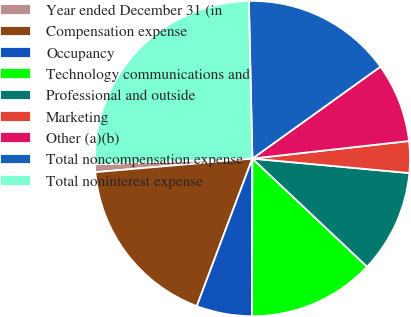<chart> <loc_0><loc_0><loc_500><loc_500><pie_chart><fcel>Year ended December 31 (in<fcel>Compensation expense<fcel>Occupancy<fcel>Technology communications and<fcel>Professional and outside<fcel>Marketing<fcel>Other (a)(b)<fcel>Total noncompensation expense<fcel>Total noninterest expense<nl><fcel>0.8%<fcel>17.89%<fcel>5.69%<fcel>13.01%<fcel>10.57%<fcel>3.24%<fcel>8.13%<fcel>15.45%<fcel>25.22%<nl></chart> 